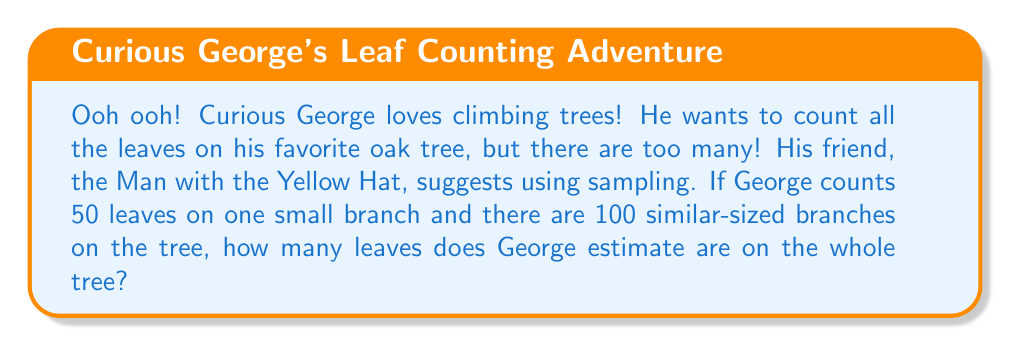Show me your answer to this math problem. Let's help Curious George solve this problem step by step:

1. Understand the sampling method:
   - George is using a small part (one branch) to represent the whole tree
   - This is called sampling, and it's useful when counting everything is too difficult

2. Identify the important information:
   - George counted 50 leaves on one small branch
   - There are 100 similar-sized branches on the tree

3. Calculate the estimate:
   - If each branch has about the same number of leaves, we can multiply:
     $$ \text{Total leaves} = \text{Leaves per branch} \times \text{Number of branches} $$
   - Plugging in our numbers:
     $$ \text{Total leaves} = 50 \times 100 = 5,000 $$

4. Interpret the result:
   - George estimates there are 5,000 leaves on the whole tree

Remember, this is an estimate! The actual number might be a little more or less, but this gives George a good idea of how many leaves are on his favorite tree.
Answer: George estimates there are 5,000 leaves on the tree. 